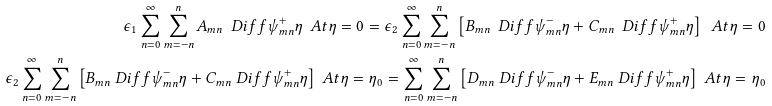<formula> <loc_0><loc_0><loc_500><loc_500>\epsilon _ { 1 } \sum _ { n = 0 } ^ { \infty } \sum _ { m = - n } ^ { n } A _ { m n } \ D i f f { \psi _ { m n } ^ { + } } { \eta } \ A t { \eta = 0 } = \epsilon _ { 2 } \sum _ { n = 0 } ^ { \infty } \sum _ { m = - n } ^ { n } \left [ B _ { m n } \ D i f f { \psi _ { m n } ^ { - } } { \eta } + C _ { m n } \ D i f f { \psi _ { m n } ^ { + } } { \eta } \right ] \ A t { \eta = 0 } \\ \epsilon _ { 2 } \sum _ { n = 0 } ^ { \infty } \sum _ { m = - n } ^ { n } \left [ B _ { m n } \ D i f f { \psi _ { m n } ^ { - } } { \eta } + C _ { m n } \ D i f f { \psi _ { m n } ^ { + } } { \eta } \right ] \ A t { \eta = \eta _ { 0 } } = \sum _ { n = 0 } ^ { \infty } \sum _ { m = - n } ^ { n } \left [ D _ { m n } \ D i f f { \psi _ { m n } ^ { - } } { \eta } + E _ { m n } \ D i f f { \psi _ { m n } ^ { + } } { \eta } \right ] \ A t { \eta = \eta _ { 0 } }</formula> 